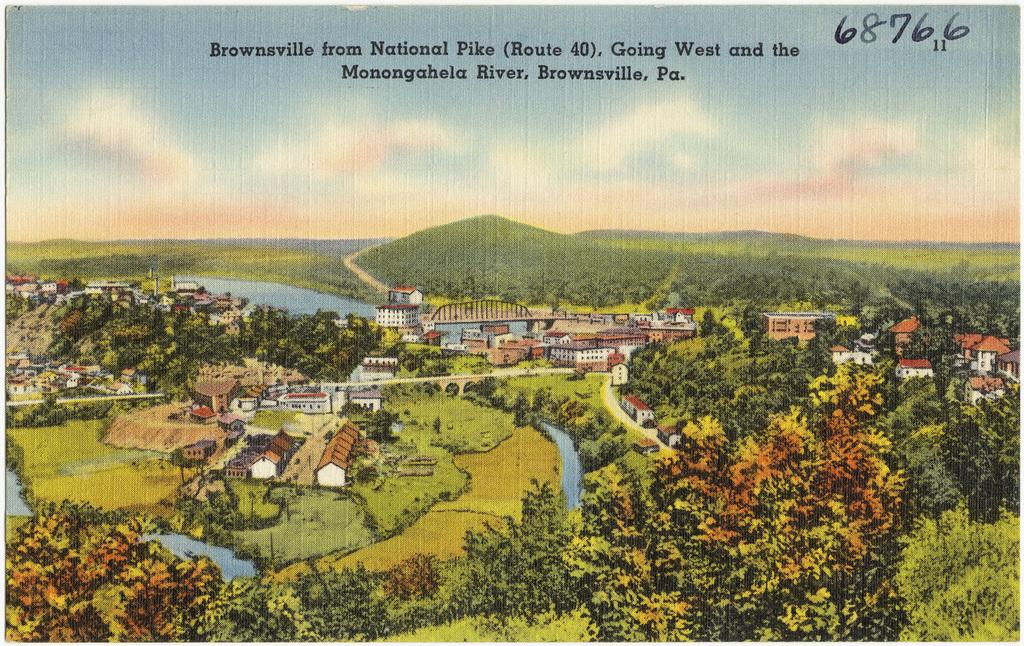<image>
Offer a succinct explanation of the picture presented. A drawing shows Monongahela River and a town in Pennsylvania. 